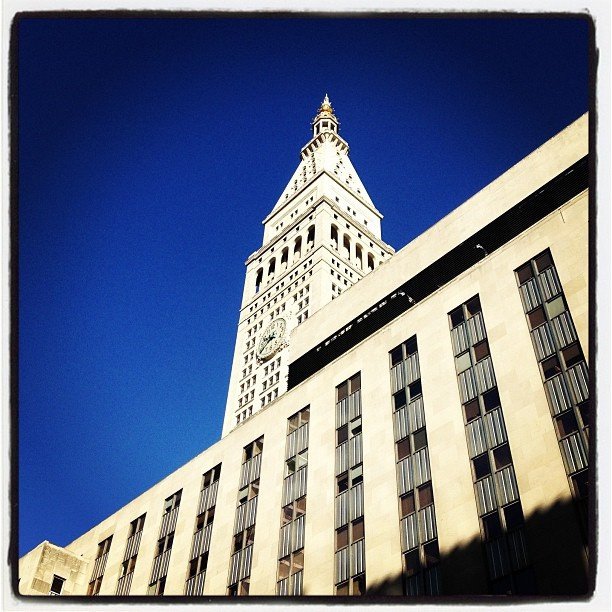Describe the objects in this image and their specific colors. I can see a clock in white, beige, darkgray, and gray tones in this image. 